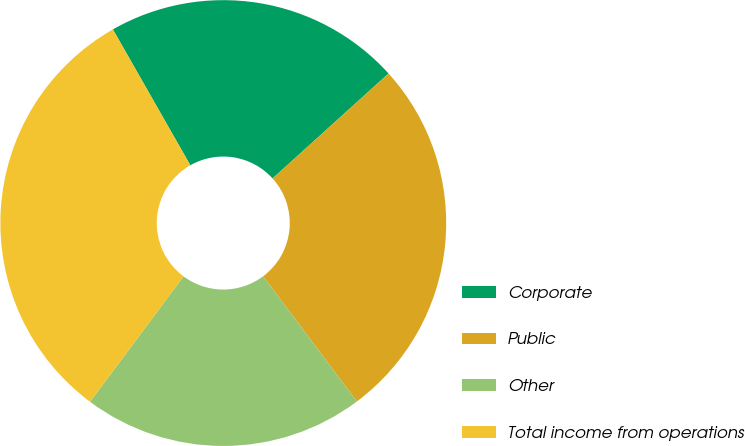<chart> <loc_0><loc_0><loc_500><loc_500><pie_chart><fcel>Corporate<fcel>Public<fcel>Other<fcel>Total income from operations<nl><fcel>21.54%<fcel>26.48%<fcel>20.42%<fcel>31.56%<nl></chart> 